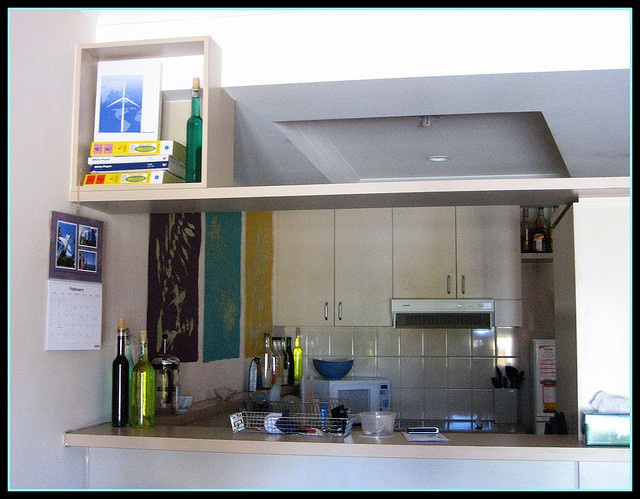Describe the objects in this image and their specific colors. I can see microwave in black, gray, and blue tones, bottle in black, darkgreen, and gray tones, bottle in black, gray, and darkgreen tones, bottle in black, white, gray, and darkgray tones, and book in black, gold, white, khaki, and darkgreen tones in this image. 